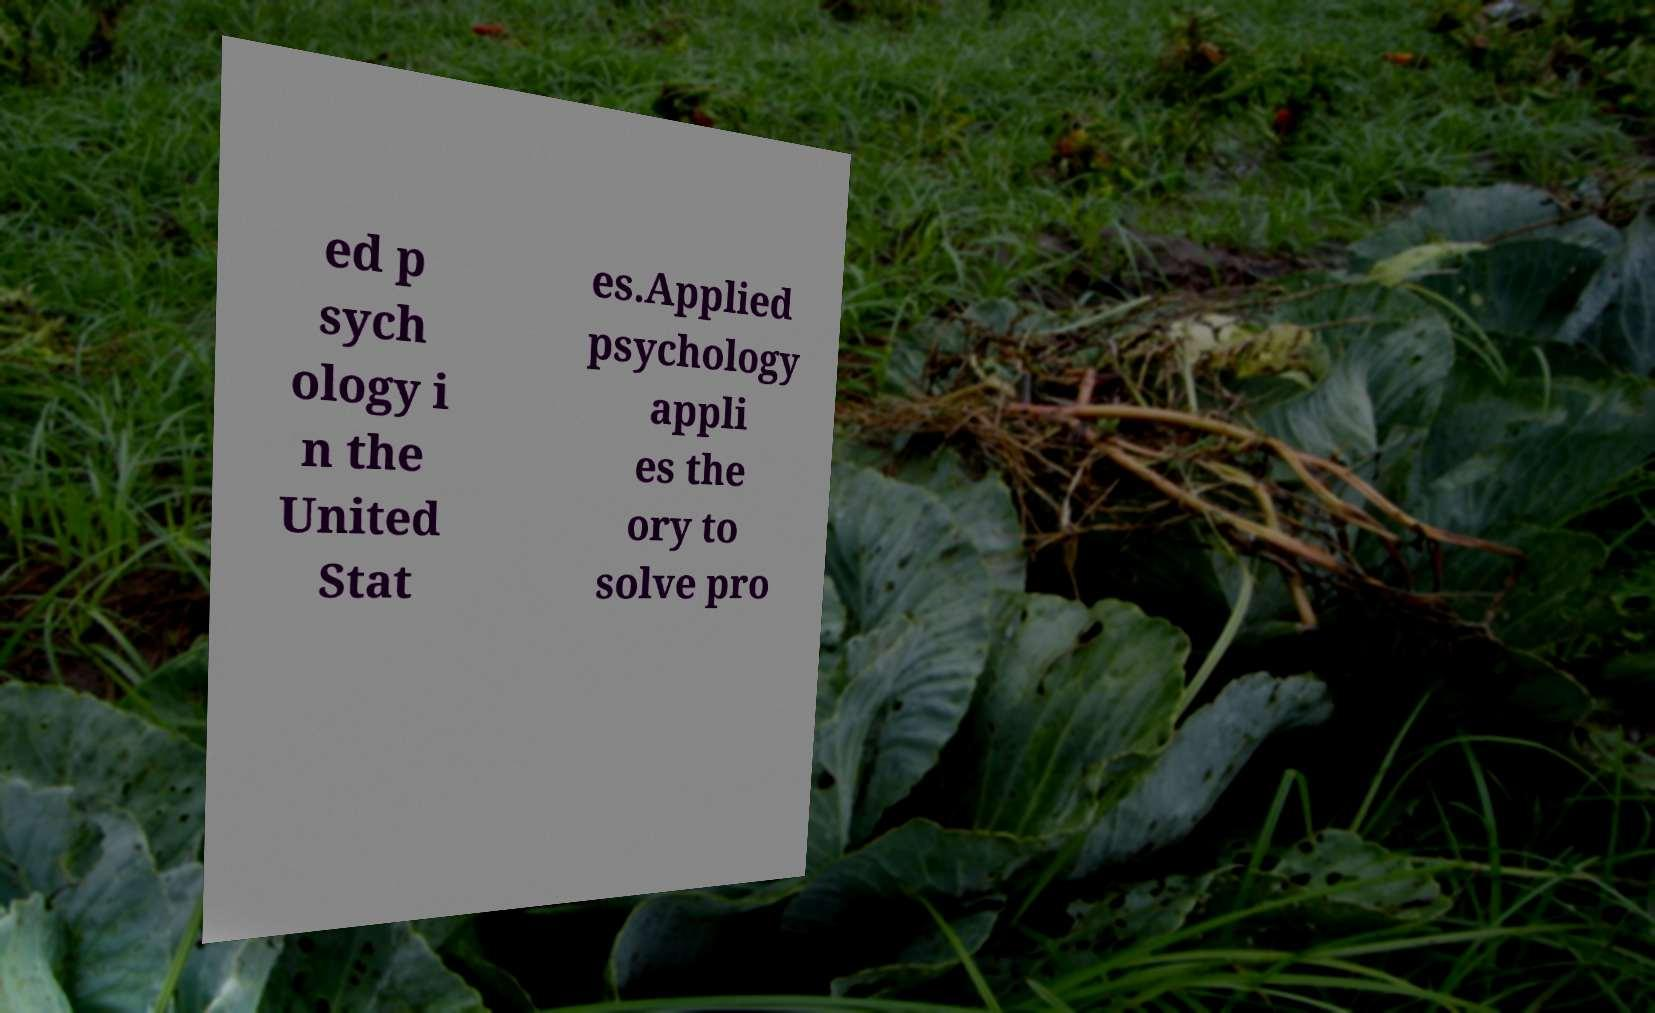There's text embedded in this image that I need extracted. Can you transcribe it verbatim? ed p sych ology i n the United Stat es.Applied psychology appli es the ory to solve pro 